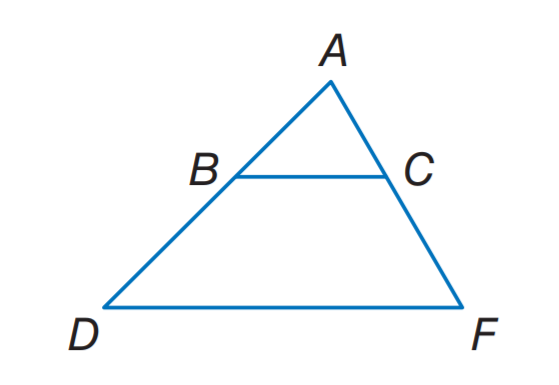Based on the image, directly select the correct answer for the following question: Question: BC \parallel DF. AB = x + 5, BD = 12, AC = 3x + 1, and CF = 15. Find x. Choices: A: 3 B: 4 C: 5 D: 6 Based on the geometric properties of the image, we're given that line segment BC is parallel to DF, which suggests the use of similar triangles in an isosceles trapezoid to solve for x. Since triangles ABD and ACF are similar (due to parallel lines and common angles at A), the ratios of their corresponding sides are equal. Therefore, AB/AC = BD/CF, which gives us (x + 5)/(3x + 1) = 12/15. Simplifying this equation, we can find the precise value of x. This is a case that requires methodical algebraic manipulation, and once the correct value of x is determined, it would correspond to one of the options provided. 